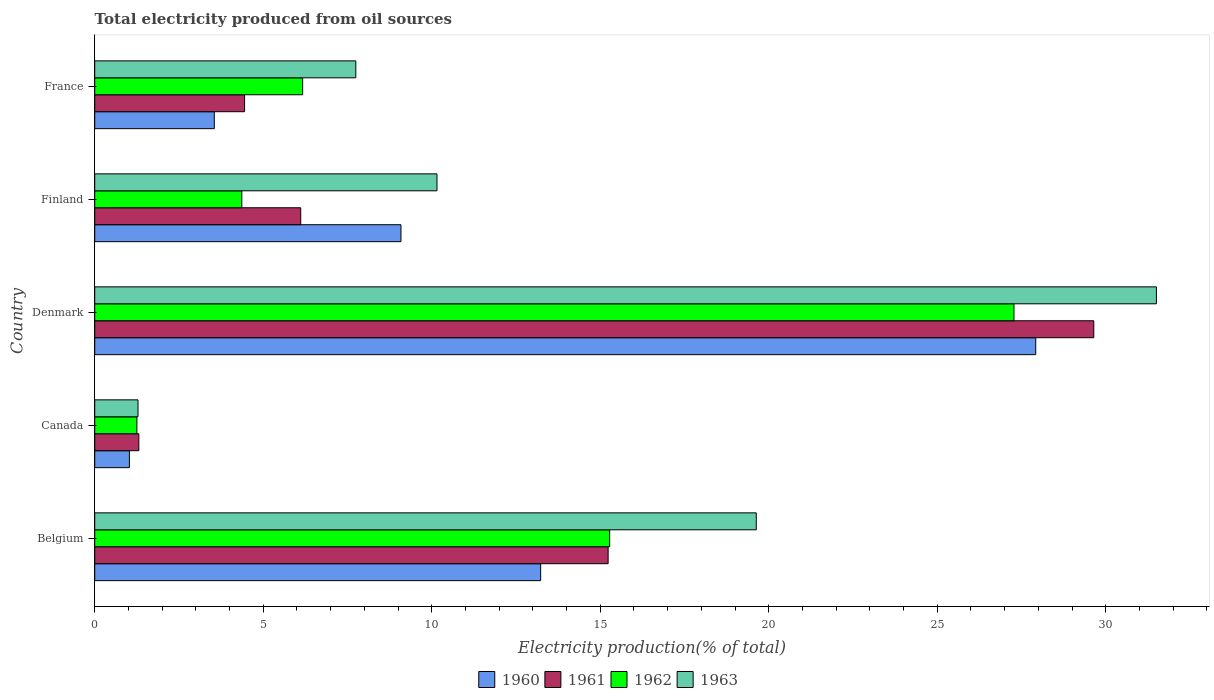How many groups of bars are there?
Make the answer very short. 5. Are the number of bars on each tick of the Y-axis equal?
Your answer should be compact. Yes. How many bars are there on the 5th tick from the top?
Offer a terse response. 4. How many bars are there on the 3rd tick from the bottom?
Your answer should be compact. 4. What is the label of the 2nd group of bars from the top?
Your answer should be very brief. Finland. What is the total electricity produced in 1961 in France?
Offer a terse response. 4.45. Across all countries, what is the maximum total electricity produced in 1963?
Your answer should be very brief. 31.51. Across all countries, what is the minimum total electricity produced in 1961?
Provide a short and direct response. 1.31. In which country was the total electricity produced in 1960 maximum?
Offer a terse response. Denmark. What is the total total electricity produced in 1961 in the graph?
Offer a terse response. 56.75. What is the difference between the total electricity produced in 1963 in Finland and that in France?
Your answer should be very brief. 2.41. What is the difference between the total electricity produced in 1961 in Denmark and the total electricity produced in 1960 in Finland?
Give a very brief answer. 20.56. What is the average total electricity produced in 1963 per country?
Keep it short and to the point. 14.06. What is the difference between the total electricity produced in 1963 and total electricity produced in 1960 in Belgium?
Provide a short and direct response. 6.4. What is the ratio of the total electricity produced in 1963 in Belgium to that in France?
Offer a terse response. 2.53. Is the difference between the total electricity produced in 1963 in Denmark and France greater than the difference between the total electricity produced in 1960 in Denmark and France?
Your answer should be compact. No. What is the difference between the highest and the second highest total electricity produced in 1963?
Your answer should be compact. 11.87. What is the difference between the highest and the lowest total electricity produced in 1962?
Your response must be concise. 26.03. Is the sum of the total electricity produced in 1960 in Belgium and Canada greater than the maximum total electricity produced in 1961 across all countries?
Offer a terse response. No. What does the 3rd bar from the bottom in Canada represents?
Keep it short and to the point. 1962. Is it the case that in every country, the sum of the total electricity produced in 1963 and total electricity produced in 1962 is greater than the total electricity produced in 1960?
Your answer should be very brief. Yes. How many countries are there in the graph?
Keep it short and to the point. 5. What is the difference between two consecutive major ticks on the X-axis?
Your answer should be very brief. 5. Where does the legend appear in the graph?
Your answer should be very brief. Bottom center. How are the legend labels stacked?
Keep it short and to the point. Horizontal. What is the title of the graph?
Ensure brevity in your answer.  Total electricity produced from oil sources. What is the label or title of the X-axis?
Your answer should be compact. Electricity production(% of total). What is the Electricity production(% of total) of 1960 in Belgium?
Offer a terse response. 13.23. What is the Electricity production(% of total) in 1961 in Belgium?
Your answer should be very brief. 15.23. What is the Electricity production(% of total) in 1962 in Belgium?
Your answer should be very brief. 15.28. What is the Electricity production(% of total) in 1963 in Belgium?
Provide a short and direct response. 19.63. What is the Electricity production(% of total) of 1960 in Canada?
Give a very brief answer. 1.03. What is the Electricity production(% of total) of 1961 in Canada?
Provide a succinct answer. 1.31. What is the Electricity production(% of total) in 1962 in Canada?
Keep it short and to the point. 1.25. What is the Electricity production(% of total) of 1963 in Canada?
Your response must be concise. 1.28. What is the Electricity production(% of total) of 1960 in Denmark?
Give a very brief answer. 27.92. What is the Electricity production(% of total) of 1961 in Denmark?
Make the answer very short. 29.65. What is the Electricity production(% of total) in 1962 in Denmark?
Keep it short and to the point. 27.28. What is the Electricity production(% of total) in 1963 in Denmark?
Ensure brevity in your answer.  31.51. What is the Electricity production(% of total) in 1960 in Finland?
Provide a succinct answer. 9.09. What is the Electricity production(% of total) in 1961 in Finland?
Give a very brief answer. 6.11. What is the Electricity production(% of total) of 1962 in Finland?
Make the answer very short. 4.36. What is the Electricity production(% of total) of 1963 in Finland?
Provide a succinct answer. 10.16. What is the Electricity production(% of total) in 1960 in France?
Offer a very short reply. 3.55. What is the Electricity production(% of total) of 1961 in France?
Give a very brief answer. 4.45. What is the Electricity production(% of total) in 1962 in France?
Your answer should be very brief. 6.17. What is the Electricity production(% of total) in 1963 in France?
Provide a short and direct response. 7.75. Across all countries, what is the maximum Electricity production(% of total) in 1960?
Your response must be concise. 27.92. Across all countries, what is the maximum Electricity production(% of total) of 1961?
Provide a short and direct response. 29.65. Across all countries, what is the maximum Electricity production(% of total) of 1962?
Keep it short and to the point. 27.28. Across all countries, what is the maximum Electricity production(% of total) in 1963?
Your answer should be compact. 31.51. Across all countries, what is the minimum Electricity production(% of total) of 1960?
Provide a short and direct response. 1.03. Across all countries, what is the minimum Electricity production(% of total) of 1961?
Make the answer very short. 1.31. Across all countries, what is the minimum Electricity production(% of total) of 1962?
Provide a succinct answer. 1.25. Across all countries, what is the minimum Electricity production(% of total) of 1963?
Your answer should be compact. 1.28. What is the total Electricity production(% of total) in 1960 in the graph?
Your answer should be compact. 54.82. What is the total Electricity production(% of total) of 1961 in the graph?
Your answer should be compact. 56.75. What is the total Electricity production(% of total) in 1962 in the graph?
Give a very brief answer. 54.34. What is the total Electricity production(% of total) in 1963 in the graph?
Provide a short and direct response. 70.32. What is the difference between the Electricity production(% of total) of 1960 in Belgium and that in Canada?
Provide a succinct answer. 12.2. What is the difference between the Electricity production(% of total) in 1961 in Belgium and that in Canada?
Make the answer very short. 13.93. What is the difference between the Electricity production(% of total) of 1962 in Belgium and that in Canada?
Keep it short and to the point. 14.03. What is the difference between the Electricity production(% of total) of 1963 in Belgium and that in Canada?
Ensure brevity in your answer.  18.35. What is the difference between the Electricity production(% of total) in 1960 in Belgium and that in Denmark?
Ensure brevity in your answer.  -14.69. What is the difference between the Electricity production(% of total) in 1961 in Belgium and that in Denmark?
Your answer should be very brief. -14.41. What is the difference between the Electricity production(% of total) in 1962 in Belgium and that in Denmark?
Give a very brief answer. -12. What is the difference between the Electricity production(% of total) of 1963 in Belgium and that in Denmark?
Offer a terse response. -11.87. What is the difference between the Electricity production(% of total) of 1960 in Belgium and that in Finland?
Your response must be concise. 4.14. What is the difference between the Electricity production(% of total) of 1961 in Belgium and that in Finland?
Give a very brief answer. 9.12. What is the difference between the Electricity production(% of total) of 1962 in Belgium and that in Finland?
Ensure brevity in your answer.  10.92. What is the difference between the Electricity production(% of total) of 1963 in Belgium and that in Finland?
Offer a very short reply. 9.47. What is the difference between the Electricity production(% of total) in 1960 in Belgium and that in France?
Ensure brevity in your answer.  9.68. What is the difference between the Electricity production(% of total) of 1961 in Belgium and that in France?
Your response must be concise. 10.79. What is the difference between the Electricity production(% of total) in 1962 in Belgium and that in France?
Your answer should be compact. 9.11. What is the difference between the Electricity production(% of total) of 1963 in Belgium and that in France?
Provide a short and direct response. 11.88. What is the difference between the Electricity production(% of total) in 1960 in Canada and that in Denmark?
Make the answer very short. -26.9. What is the difference between the Electricity production(% of total) of 1961 in Canada and that in Denmark?
Offer a very short reply. -28.34. What is the difference between the Electricity production(% of total) in 1962 in Canada and that in Denmark?
Provide a short and direct response. -26.03. What is the difference between the Electricity production(% of total) in 1963 in Canada and that in Denmark?
Offer a very short reply. -30.22. What is the difference between the Electricity production(% of total) of 1960 in Canada and that in Finland?
Your answer should be compact. -8.06. What is the difference between the Electricity production(% of total) of 1961 in Canada and that in Finland?
Your answer should be very brief. -4.8. What is the difference between the Electricity production(% of total) in 1962 in Canada and that in Finland?
Your answer should be compact. -3.11. What is the difference between the Electricity production(% of total) of 1963 in Canada and that in Finland?
Make the answer very short. -8.87. What is the difference between the Electricity production(% of total) of 1960 in Canada and that in France?
Your answer should be very brief. -2.52. What is the difference between the Electricity production(% of total) of 1961 in Canada and that in France?
Your response must be concise. -3.14. What is the difference between the Electricity production(% of total) in 1962 in Canada and that in France?
Keep it short and to the point. -4.92. What is the difference between the Electricity production(% of total) in 1963 in Canada and that in France?
Offer a very short reply. -6.46. What is the difference between the Electricity production(% of total) of 1960 in Denmark and that in Finland?
Ensure brevity in your answer.  18.84. What is the difference between the Electricity production(% of total) in 1961 in Denmark and that in Finland?
Your answer should be compact. 23.53. What is the difference between the Electricity production(% of total) in 1962 in Denmark and that in Finland?
Provide a short and direct response. 22.91. What is the difference between the Electricity production(% of total) of 1963 in Denmark and that in Finland?
Offer a terse response. 21.35. What is the difference between the Electricity production(% of total) of 1960 in Denmark and that in France?
Make the answer very short. 24.38. What is the difference between the Electricity production(% of total) of 1961 in Denmark and that in France?
Offer a terse response. 25.2. What is the difference between the Electricity production(% of total) in 1962 in Denmark and that in France?
Keep it short and to the point. 21.11. What is the difference between the Electricity production(% of total) in 1963 in Denmark and that in France?
Make the answer very short. 23.76. What is the difference between the Electricity production(% of total) in 1960 in Finland and that in France?
Offer a terse response. 5.54. What is the difference between the Electricity production(% of total) in 1961 in Finland and that in France?
Your answer should be very brief. 1.67. What is the difference between the Electricity production(% of total) in 1962 in Finland and that in France?
Give a very brief answer. -1.8. What is the difference between the Electricity production(% of total) in 1963 in Finland and that in France?
Your answer should be very brief. 2.41. What is the difference between the Electricity production(% of total) of 1960 in Belgium and the Electricity production(% of total) of 1961 in Canada?
Your answer should be compact. 11.92. What is the difference between the Electricity production(% of total) of 1960 in Belgium and the Electricity production(% of total) of 1962 in Canada?
Your response must be concise. 11.98. What is the difference between the Electricity production(% of total) in 1960 in Belgium and the Electricity production(% of total) in 1963 in Canada?
Your answer should be compact. 11.95. What is the difference between the Electricity production(% of total) of 1961 in Belgium and the Electricity production(% of total) of 1962 in Canada?
Offer a terse response. 13.98. What is the difference between the Electricity production(% of total) of 1961 in Belgium and the Electricity production(% of total) of 1963 in Canada?
Give a very brief answer. 13.95. What is the difference between the Electricity production(% of total) of 1962 in Belgium and the Electricity production(% of total) of 1963 in Canada?
Provide a short and direct response. 14. What is the difference between the Electricity production(% of total) of 1960 in Belgium and the Electricity production(% of total) of 1961 in Denmark?
Your answer should be very brief. -16.41. What is the difference between the Electricity production(% of total) in 1960 in Belgium and the Electricity production(% of total) in 1962 in Denmark?
Make the answer very short. -14.05. What is the difference between the Electricity production(% of total) of 1960 in Belgium and the Electricity production(% of total) of 1963 in Denmark?
Offer a very short reply. -18.27. What is the difference between the Electricity production(% of total) of 1961 in Belgium and the Electricity production(% of total) of 1962 in Denmark?
Offer a very short reply. -12.04. What is the difference between the Electricity production(% of total) in 1961 in Belgium and the Electricity production(% of total) in 1963 in Denmark?
Provide a short and direct response. -16.27. What is the difference between the Electricity production(% of total) in 1962 in Belgium and the Electricity production(% of total) in 1963 in Denmark?
Your response must be concise. -16.22. What is the difference between the Electricity production(% of total) of 1960 in Belgium and the Electricity production(% of total) of 1961 in Finland?
Offer a very short reply. 7.12. What is the difference between the Electricity production(% of total) of 1960 in Belgium and the Electricity production(% of total) of 1962 in Finland?
Make the answer very short. 8.87. What is the difference between the Electricity production(% of total) of 1960 in Belgium and the Electricity production(% of total) of 1963 in Finland?
Your answer should be very brief. 3.08. What is the difference between the Electricity production(% of total) in 1961 in Belgium and the Electricity production(% of total) in 1962 in Finland?
Your answer should be very brief. 10.87. What is the difference between the Electricity production(% of total) of 1961 in Belgium and the Electricity production(% of total) of 1963 in Finland?
Make the answer very short. 5.08. What is the difference between the Electricity production(% of total) in 1962 in Belgium and the Electricity production(% of total) in 1963 in Finland?
Offer a very short reply. 5.12. What is the difference between the Electricity production(% of total) in 1960 in Belgium and the Electricity production(% of total) in 1961 in France?
Provide a succinct answer. 8.79. What is the difference between the Electricity production(% of total) in 1960 in Belgium and the Electricity production(% of total) in 1962 in France?
Your answer should be very brief. 7.06. What is the difference between the Electricity production(% of total) of 1960 in Belgium and the Electricity production(% of total) of 1963 in France?
Your answer should be compact. 5.48. What is the difference between the Electricity production(% of total) in 1961 in Belgium and the Electricity production(% of total) in 1962 in France?
Your response must be concise. 9.07. What is the difference between the Electricity production(% of total) of 1961 in Belgium and the Electricity production(% of total) of 1963 in France?
Make the answer very short. 7.49. What is the difference between the Electricity production(% of total) of 1962 in Belgium and the Electricity production(% of total) of 1963 in France?
Provide a short and direct response. 7.53. What is the difference between the Electricity production(% of total) of 1960 in Canada and the Electricity production(% of total) of 1961 in Denmark?
Give a very brief answer. -28.62. What is the difference between the Electricity production(% of total) of 1960 in Canada and the Electricity production(% of total) of 1962 in Denmark?
Give a very brief answer. -26.25. What is the difference between the Electricity production(% of total) of 1960 in Canada and the Electricity production(% of total) of 1963 in Denmark?
Offer a terse response. -30.48. What is the difference between the Electricity production(% of total) in 1961 in Canada and the Electricity production(% of total) in 1962 in Denmark?
Provide a succinct answer. -25.97. What is the difference between the Electricity production(% of total) in 1961 in Canada and the Electricity production(% of total) in 1963 in Denmark?
Your answer should be compact. -30.2. What is the difference between the Electricity production(% of total) of 1962 in Canada and the Electricity production(% of total) of 1963 in Denmark?
Provide a succinct answer. -30.25. What is the difference between the Electricity production(% of total) in 1960 in Canada and the Electricity production(% of total) in 1961 in Finland?
Provide a short and direct response. -5.08. What is the difference between the Electricity production(% of total) of 1960 in Canada and the Electricity production(% of total) of 1962 in Finland?
Your response must be concise. -3.34. What is the difference between the Electricity production(% of total) of 1960 in Canada and the Electricity production(% of total) of 1963 in Finland?
Your answer should be compact. -9.13. What is the difference between the Electricity production(% of total) of 1961 in Canada and the Electricity production(% of total) of 1962 in Finland?
Provide a short and direct response. -3.06. What is the difference between the Electricity production(% of total) in 1961 in Canada and the Electricity production(% of total) in 1963 in Finland?
Provide a succinct answer. -8.85. What is the difference between the Electricity production(% of total) in 1962 in Canada and the Electricity production(% of total) in 1963 in Finland?
Offer a very short reply. -8.91. What is the difference between the Electricity production(% of total) in 1960 in Canada and the Electricity production(% of total) in 1961 in France?
Offer a terse response. -3.42. What is the difference between the Electricity production(% of total) in 1960 in Canada and the Electricity production(% of total) in 1962 in France?
Make the answer very short. -5.14. What is the difference between the Electricity production(% of total) in 1960 in Canada and the Electricity production(% of total) in 1963 in France?
Ensure brevity in your answer.  -6.72. What is the difference between the Electricity production(% of total) of 1961 in Canada and the Electricity production(% of total) of 1962 in France?
Ensure brevity in your answer.  -4.86. What is the difference between the Electricity production(% of total) of 1961 in Canada and the Electricity production(% of total) of 1963 in France?
Provide a short and direct response. -6.44. What is the difference between the Electricity production(% of total) of 1962 in Canada and the Electricity production(% of total) of 1963 in France?
Offer a terse response. -6.5. What is the difference between the Electricity production(% of total) of 1960 in Denmark and the Electricity production(% of total) of 1961 in Finland?
Provide a short and direct response. 21.81. What is the difference between the Electricity production(% of total) in 1960 in Denmark and the Electricity production(% of total) in 1962 in Finland?
Your answer should be very brief. 23.56. What is the difference between the Electricity production(% of total) of 1960 in Denmark and the Electricity production(% of total) of 1963 in Finland?
Your answer should be compact. 17.77. What is the difference between the Electricity production(% of total) in 1961 in Denmark and the Electricity production(% of total) in 1962 in Finland?
Your answer should be very brief. 25.28. What is the difference between the Electricity production(% of total) of 1961 in Denmark and the Electricity production(% of total) of 1963 in Finland?
Provide a short and direct response. 19.49. What is the difference between the Electricity production(% of total) in 1962 in Denmark and the Electricity production(% of total) in 1963 in Finland?
Make the answer very short. 17.12. What is the difference between the Electricity production(% of total) in 1960 in Denmark and the Electricity production(% of total) in 1961 in France?
Keep it short and to the point. 23.48. What is the difference between the Electricity production(% of total) of 1960 in Denmark and the Electricity production(% of total) of 1962 in France?
Provide a short and direct response. 21.75. What is the difference between the Electricity production(% of total) of 1960 in Denmark and the Electricity production(% of total) of 1963 in France?
Ensure brevity in your answer.  20.18. What is the difference between the Electricity production(% of total) of 1961 in Denmark and the Electricity production(% of total) of 1962 in France?
Keep it short and to the point. 23.48. What is the difference between the Electricity production(% of total) in 1961 in Denmark and the Electricity production(% of total) in 1963 in France?
Offer a very short reply. 21.9. What is the difference between the Electricity production(% of total) in 1962 in Denmark and the Electricity production(% of total) in 1963 in France?
Ensure brevity in your answer.  19.53. What is the difference between the Electricity production(% of total) in 1960 in Finland and the Electricity production(% of total) in 1961 in France?
Your response must be concise. 4.64. What is the difference between the Electricity production(% of total) of 1960 in Finland and the Electricity production(% of total) of 1962 in France?
Offer a very short reply. 2.92. What is the difference between the Electricity production(% of total) of 1960 in Finland and the Electricity production(% of total) of 1963 in France?
Your answer should be compact. 1.34. What is the difference between the Electricity production(% of total) of 1961 in Finland and the Electricity production(% of total) of 1962 in France?
Provide a short and direct response. -0.06. What is the difference between the Electricity production(% of total) in 1961 in Finland and the Electricity production(% of total) in 1963 in France?
Offer a very short reply. -1.64. What is the difference between the Electricity production(% of total) of 1962 in Finland and the Electricity production(% of total) of 1963 in France?
Offer a terse response. -3.38. What is the average Electricity production(% of total) in 1960 per country?
Make the answer very short. 10.96. What is the average Electricity production(% of total) in 1961 per country?
Provide a succinct answer. 11.35. What is the average Electricity production(% of total) of 1962 per country?
Your response must be concise. 10.87. What is the average Electricity production(% of total) of 1963 per country?
Provide a succinct answer. 14.06. What is the difference between the Electricity production(% of total) in 1960 and Electricity production(% of total) in 1961 in Belgium?
Make the answer very short. -2. What is the difference between the Electricity production(% of total) of 1960 and Electricity production(% of total) of 1962 in Belgium?
Your answer should be very brief. -2.05. What is the difference between the Electricity production(% of total) of 1960 and Electricity production(% of total) of 1963 in Belgium?
Provide a short and direct response. -6.4. What is the difference between the Electricity production(% of total) in 1961 and Electricity production(% of total) in 1962 in Belgium?
Offer a very short reply. -0.05. What is the difference between the Electricity production(% of total) in 1961 and Electricity production(% of total) in 1963 in Belgium?
Your response must be concise. -4.4. What is the difference between the Electricity production(% of total) of 1962 and Electricity production(% of total) of 1963 in Belgium?
Ensure brevity in your answer.  -4.35. What is the difference between the Electricity production(% of total) in 1960 and Electricity production(% of total) in 1961 in Canada?
Ensure brevity in your answer.  -0.28. What is the difference between the Electricity production(% of total) in 1960 and Electricity production(% of total) in 1962 in Canada?
Your response must be concise. -0.22. What is the difference between the Electricity production(% of total) of 1960 and Electricity production(% of total) of 1963 in Canada?
Your answer should be compact. -0.26. What is the difference between the Electricity production(% of total) in 1961 and Electricity production(% of total) in 1962 in Canada?
Make the answer very short. 0.06. What is the difference between the Electricity production(% of total) in 1961 and Electricity production(% of total) in 1963 in Canada?
Make the answer very short. 0.03. What is the difference between the Electricity production(% of total) of 1962 and Electricity production(% of total) of 1963 in Canada?
Offer a terse response. -0.03. What is the difference between the Electricity production(% of total) in 1960 and Electricity production(% of total) in 1961 in Denmark?
Your response must be concise. -1.72. What is the difference between the Electricity production(% of total) in 1960 and Electricity production(% of total) in 1962 in Denmark?
Offer a very short reply. 0.65. What is the difference between the Electricity production(% of total) in 1960 and Electricity production(% of total) in 1963 in Denmark?
Make the answer very short. -3.58. What is the difference between the Electricity production(% of total) of 1961 and Electricity production(% of total) of 1962 in Denmark?
Provide a succinct answer. 2.37. What is the difference between the Electricity production(% of total) of 1961 and Electricity production(% of total) of 1963 in Denmark?
Provide a succinct answer. -1.86. What is the difference between the Electricity production(% of total) in 1962 and Electricity production(% of total) in 1963 in Denmark?
Provide a short and direct response. -4.23. What is the difference between the Electricity production(% of total) in 1960 and Electricity production(% of total) in 1961 in Finland?
Provide a short and direct response. 2.98. What is the difference between the Electricity production(% of total) in 1960 and Electricity production(% of total) in 1962 in Finland?
Offer a very short reply. 4.72. What is the difference between the Electricity production(% of total) of 1960 and Electricity production(% of total) of 1963 in Finland?
Provide a succinct answer. -1.07. What is the difference between the Electricity production(% of total) of 1961 and Electricity production(% of total) of 1962 in Finland?
Keep it short and to the point. 1.75. What is the difference between the Electricity production(% of total) in 1961 and Electricity production(% of total) in 1963 in Finland?
Give a very brief answer. -4.04. What is the difference between the Electricity production(% of total) in 1962 and Electricity production(% of total) in 1963 in Finland?
Ensure brevity in your answer.  -5.79. What is the difference between the Electricity production(% of total) in 1960 and Electricity production(% of total) in 1961 in France?
Your response must be concise. -0.9. What is the difference between the Electricity production(% of total) in 1960 and Electricity production(% of total) in 1962 in France?
Ensure brevity in your answer.  -2.62. What is the difference between the Electricity production(% of total) in 1960 and Electricity production(% of total) in 1963 in France?
Keep it short and to the point. -4.2. What is the difference between the Electricity production(% of total) of 1961 and Electricity production(% of total) of 1962 in France?
Your response must be concise. -1.72. What is the difference between the Electricity production(% of total) in 1961 and Electricity production(% of total) in 1963 in France?
Give a very brief answer. -3.3. What is the difference between the Electricity production(% of total) of 1962 and Electricity production(% of total) of 1963 in France?
Offer a terse response. -1.58. What is the ratio of the Electricity production(% of total) of 1960 in Belgium to that in Canada?
Provide a short and direct response. 12.86. What is the ratio of the Electricity production(% of total) of 1961 in Belgium to that in Canada?
Your answer should be very brief. 11.64. What is the ratio of the Electricity production(% of total) in 1962 in Belgium to that in Canada?
Ensure brevity in your answer.  12.21. What is the ratio of the Electricity production(% of total) in 1963 in Belgium to that in Canada?
Provide a short and direct response. 15.29. What is the ratio of the Electricity production(% of total) of 1960 in Belgium to that in Denmark?
Keep it short and to the point. 0.47. What is the ratio of the Electricity production(% of total) in 1961 in Belgium to that in Denmark?
Make the answer very short. 0.51. What is the ratio of the Electricity production(% of total) in 1962 in Belgium to that in Denmark?
Your answer should be compact. 0.56. What is the ratio of the Electricity production(% of total) of 1963 in Belgium to that in Denmark?
Provide a short and direct response. 0.62. What is the ratio of the Electricity production(% of total) in 1960 in Belgium to that in Finland?
Your answer should be very brief. 1.46. What is the ratio of the Electricity production(% of total) in 1961 in Belgium to that in Finland?
Your answer should be very brief. 2.49. What is the ratio of the Electricity production(% of total) in 1962 in Belgium to that in Finland?
Offer a terse response. 3.5. What is the ratio of the Electricity production(% of total) of 1963 in Belgium to that in Finland?
Keep it short and to the point. 1.93. What is the ratio of the Electricity production(% of total) of 1960 in Belgium to that in France?
Your answer should be compact. 3.73. What is the ratio of the Electricity production(% of total) of 1961 in Belgium to that in France?
Make the answer very short. 3.43. What is the ratio of the Electricity production(% of total) in 1962 in Belgium to that in France?
Give a very brief answer. 2.48. What is the ratio of the Electricity production(% of total) of 1963 in Belgium to that in France?
Your answer should be compact. 2.53. What is the ratio of the Electricity production(% of total) of 1960 in Canada to that in Denmark?
Provide a succinct answer. 0.04. What is the ratio of the Electricity production(% of total) in 1961 in Canada to that in Denmark?
Ensure brevity in your answer.  0.04. What is the ratio of the Electricity production(% of total) of 1962 in Canada to that in Denmark?
Offer a terse response. 0.05. What is the ratio of the Electricity production(% of total) in 1963 in Canada to that in Denmark?
Ensure brevity in your answer.  0.04. What is the ratio of the Electricity production(% of total) in 1960 in Canada to that in Finland?
Your response must be concise. 0.11. What is the ratio of the Electricity production(% of total) in 1961 in Canada to that in Finland?
Your answer should be compact. 0.21. What is the ratio of the Electricity production(% of total) in 1962 in Canada to that in Finland?
Ensure brevity in your answer.  0.29. What is the ratio of the Electricity production(% of total) in 1963 in Canada to that in Finland?
Your answer should be compact. 0.13. What is the ratio of the Electricity production(% of total) in 1960 in Canada to that in France?
Make the answer very short. 0.29. What is the ratio of the Electricity production(% of total) in 1961 in Canada to that in France?
Your response must be concise. 0.29. What is the ratio of the Electricity production(% of total) of 1962 in Canada to that in France?
Keep it short and to the point. 0.2. What is the ratio of the Electricity production(% of total) in 1963 in Canada to that in France?
Ensure brevity in your answer.  0.17. What is the ratio of the Electricity production(% of total) of 1960 in Denmark to that in Finland?
Your answer should be compact. 3.07. What is the ratio of the Electricity production(% of total) of 1961 in Denmark to that in Finland?
Your answer should be very brief. 4.85. What is the ratio of the Electricity production(% of total) of 1962 in Denmark to that in Finland?
Give a very brief answer. 6.25. What is the ratio of the Electricity production(% of total) in 1963 in Denmark to that in Finland?
Keep it short and to the point. 3.1. What is the ratio of the Electricity production(% of total) of 1960 in Denmark to that in France?
Your answer should be very brief. 7.87. What is the ratio of the Electricity production(% of total) of 1961 in Denmark to that in France?
Your response must be concise. 6.67. What is the ratio of the Electricity production(% of total) in 1962 in Denmark to that in France?
Keep it short and to the point. 4.42. What is the ratio of the Electricity production(% of total) in 1963 in Denmark to that in France?
Your answer should be compact. 4.07. What is the ratio of the Electricity production(% of total) in 1960 in Finland to that in France?
Provide a succinct answer. 2.56. What is the ratio of the Electricity production(% of total) of 1961 in Finland to that in France?
Give a very brief answer. 1.37. What is the ratio of the Electricity production(% of total) of 1962 in Finland to that in France?
Offer a very short reply. 0.71. What is the ratio of the Electricity production(% of total) in 1963 in Finland to that in France?
Make the answer very short. 1.31. What is the difference between the highest and the second highest Electricity production(% of total) in 1960?
Give a very brief answer. 14.69. What is the difference between the highest and the second highest Electricity production(% of total) in 1961?
Offer a very short reply. 14.41. What is the difference between the highest and the second highest Electricity production(% of total) in 1962?
Make the answer very short. 12. What is the difference between the highest and the second highest Electricity production(% of total) of 1963?
Ensure brevity in your answer.  11.87. What is the difference between the highest and the lowest Electricity production(% of total) of 1960?
Keep it short and to the point. 26.9. What is the difference between the highest and the lowest Electricity production(% of total) of 1961?
Give a very brief answer. 28.34. What is the difference between the highest and the lowest Electricity production(% of total) in 1962?
Provide a succinct answer. 26.03. What is the difference between the highest and the lowest Electricity production(% of total) in 1963?
Ensure brevity in your answer.  30.22. 